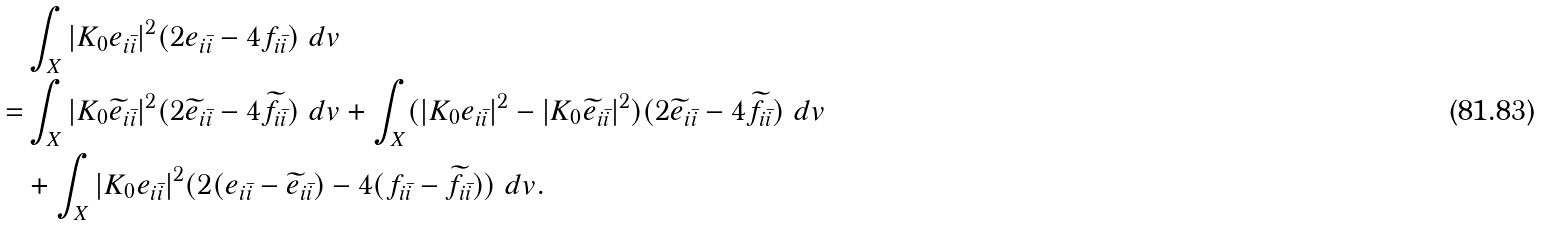Convert formula to latex. <formula><loc_0><loc_0><loc_500><loc_500>& \int _ { X } | K _ { 0 } e _ { i \bar { i } } | ^ { 2 } ( 2 e _ { i \bar { i } } - 4 f _ { i \bar { i } } ) \ d v \\ = & \int _ { X } | K _ { 0 } \widetilde { e } _ { i \bar { i } } | ^ { 2 } ( 2 \widetilde { e } _ { i \bar { i } } - 4 \widetilde { f } _ { i \bar { i } } ) \ d v + \int _ { X } ( | K _ { 0 } e _ { i \bar { i } } | ^ { 2 } - | K _ { 0 } \widetilde { e } _ { i \bar { i } } | ^ { 2 } ) ( 2 \widetilde { e } _ { i \bar { i } } - 4 \widetilde { f } _ { i \bar { i } } ) \ d v \\ & + \int _ { X } | K _ { 0 } e _ { i \bar { i } } | ^ { 2 } ( 2 ( e _ { i \bar { i } } - \widetilde { e } _ { i \bar { i } } ) - 4 ( f _ { i \bar { i } } - \widetilde { f } _ { i \bar { i } } ) ) \ d v .</formula> 